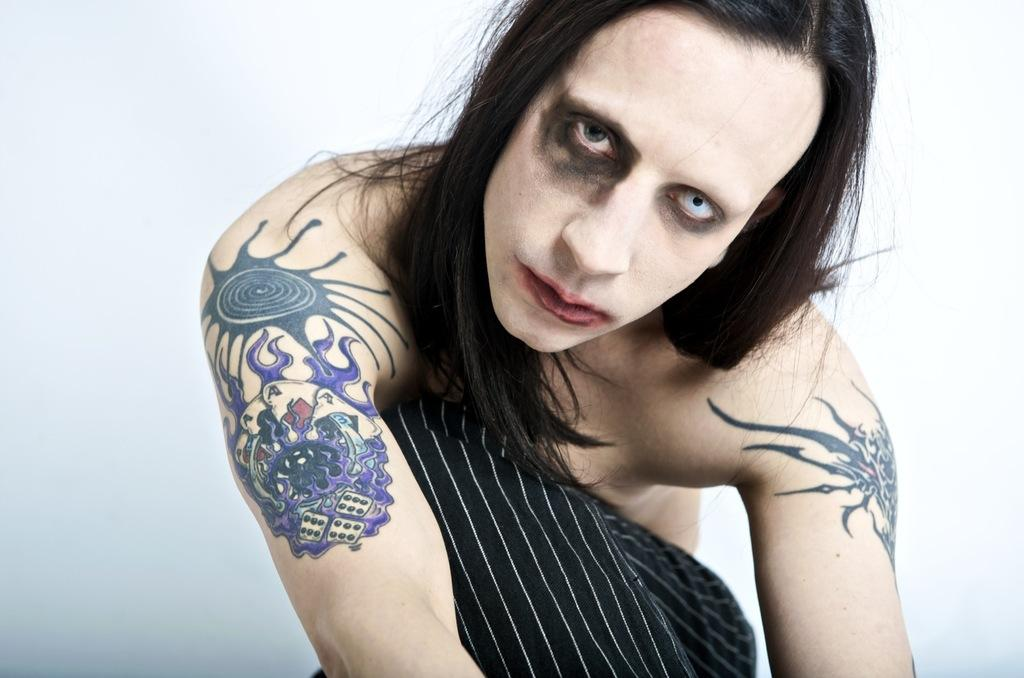What is the main subject of the image? There is a person in the image. What distinguishing feature can be seen on the person? The person has tattoos. What type of material is visible in the image? There is cloth visible in the image. What color is the background of the image? The background of the image is white. What type of amusement can be seen in the image? There is no amusement present in the image; it features a person with tattoos against a white background. How does the person measure the distance between their knee and the ground in the image? There is no indication of measuring distance or showing a knee in the image. 